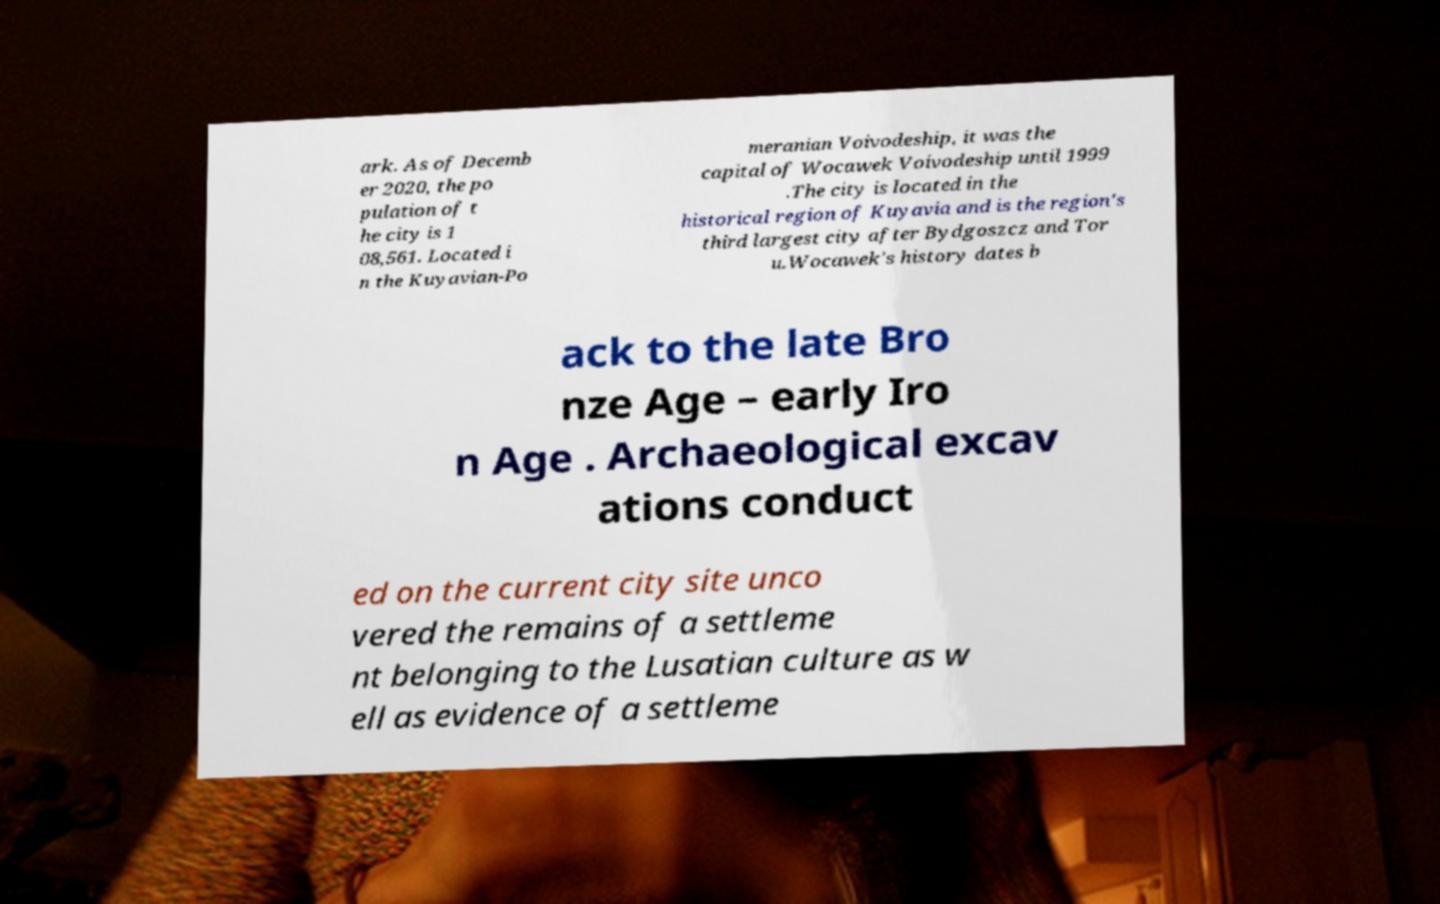Can you read and provide the text displayed in the image?This photo seems to have some interesting text. Can you extract and type it out for me? ark. As of Decemb er 2020, the po pulation of t he city is 1 08,561. Located i n the Kuyavian-Po meranian Voivodeship, it was the capital of Wocawek Voivodeship until 1999 .The city is located in the historical region of Kuyavia and is the region's third largest city after Bydgoszcz and Tor u.Wocawek's history dates b ack to the late Bro nze Age – early Iro n Age . Archaeological excav ations conduct ed on the current city site unco vered the remains of a settleme nt belonging to the Lusatian culture as w ell as evidence of a settleme 